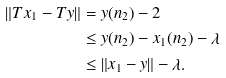<formula> <loc_0><loc_0><loc_500><loc_500>\| T x _ { 1 } - T y \| & = y ( n _ { 2 } ) - 2 \\ & \leq y ( n _ { 2 } ) - x _ { 1 } ( n _ { 2 } ) - \lambda \\ & \leq \| x _ { 1 } - y \| - \lambda .</formula> 